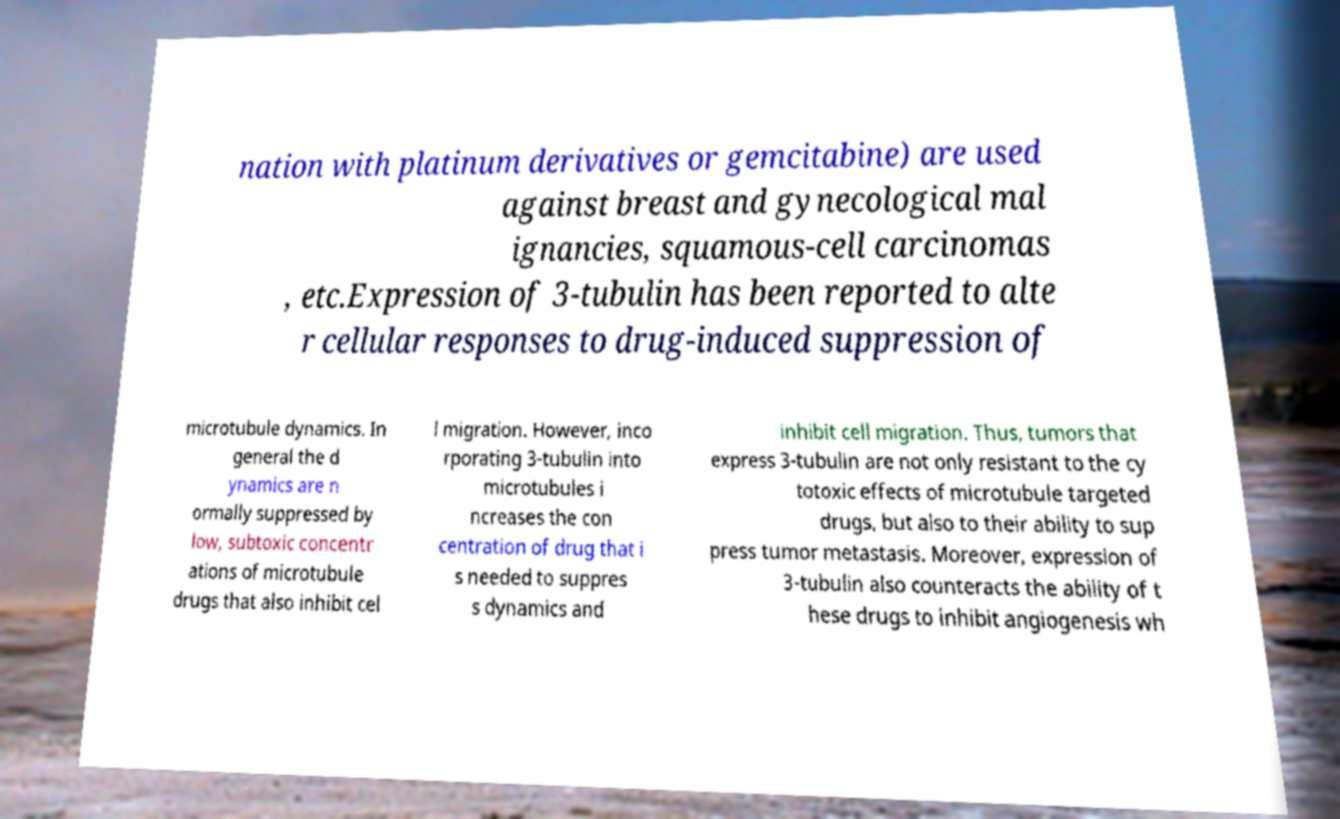Please read and relay the text visible in this image. What does it say? nation with platinum derivatives or gemcitabine) are used against breast and gynecological mal ignancies, squamous-cell carcinomas , etc.Expression of 3-tubulin has been reported to alte r cellular responses to drug-induced suppression of microtubule dynamics. In general the d ynamics are n ormally suppressed by low, subtoxic concentr ations of microtubule drugs that also inhibit cel l migration. However, inco rporating 3-tubulin into microtubules i ncreases the con centration of drug that i s needed to suppres s dynamics and inhibit cell migration. Thus, tumors that express 3-tubulin are not only resistant to the cy totoxic effects of microtubule targeted drugs, but also to their ability to sup press tumor metastasis. Moreover, expression of 3-tubulin also counteracts the ability of t hese drugs to inhibit angiogenesis wh 